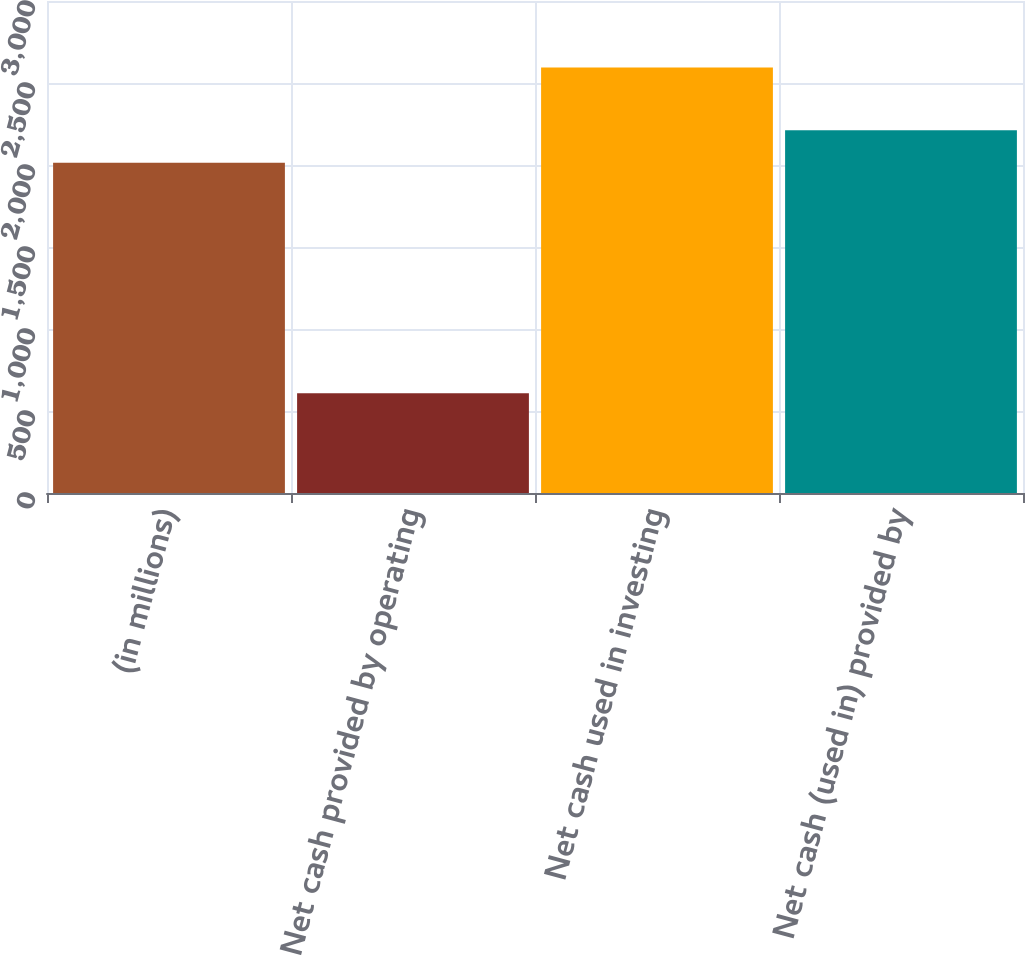<chart> <loc_0><loc_0><loc_500><loc_500><bar_chart><fcel>(in millions)<fcel>Net cash provided by operating<fcel>Net cash used in investing<fcel>Net cash (used in) provided by<nl><fcel>2014<fcel>608.3<fcel>2594.1<fcel>2212.58<nl></chart> 